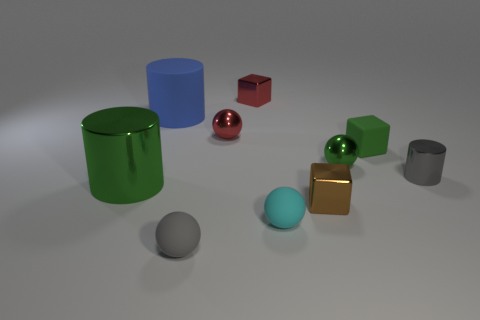The small metallic cylinder is what color?
Make the answer very short. Gray. What number of other spheres are the same material as the tiny gray sphere?
Your answer should be compact. 1. Are there more cyan matte objects than shiny objects?
Your answer should be compact. No. What number of red things are on the right side of the metal cylinder that is on the right side of the small rubber cube?
Provide a succinct answer. 0. How many objects are tiny cubes that are right of the small cyan matte sphere or big gray balls?
Keep it short and to the point. 2. Is there another large object that has the same shape as the gray metallic object?
Give a very brief answer. Yes. There is a gray thing that is in front of the gray object behind the brown shiny block; what is its shape?
Your answer should be very brief. Sphere. How many balls are either cyan objects or big objects?
Provide a short and direct response. 1. There is a object that is the same color as the tiny cylinder; what is its material?
Your response must be concise. Rubber. Is the shape of the gray object in front of the brown metallic block the same as the small matte thing behind the big shiny cylinder?
Your answer should be compact. No. 